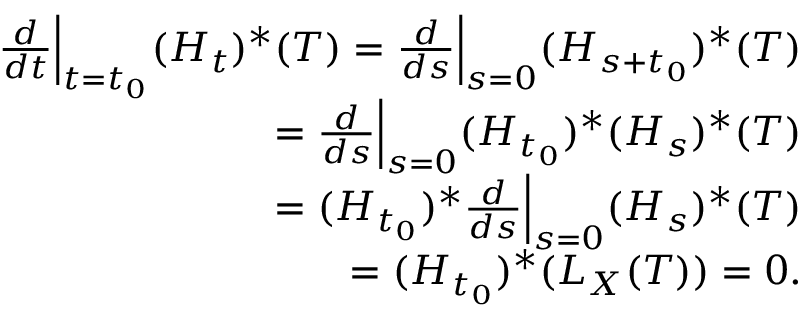<formula> <loc_0><loc_0><loc_500><loc_500>\begin{array} { r } { \frac { d } { d t } \left | _ { t = t _ { 0 } } ( H _ { t } ) ^ { * } ( T ) = \frac { d } { d s } \right | _ { s = 0 } ( H _ { s + t _ { 0 } } ) ^ { * } ( T ) } \\ { = \frac { d } { d s } \left | _ { s = 0 } ( H _ { t _ { 0 } } ) ^ { * } ( H _ { s } ) ^ { * } ( T ) } \\ { = ( H _ { t _ { 0 } } ) ^ { * } \frac { d } { d s } \right | _ { s = 0 } ( H _ { s } ) ^ { * } ( T ) } \\ { = ( H _ { t _ { 0 } } ) ^ { * } ( L _ { X } ( T ) ) = 0 . } \end{array}</formula> 